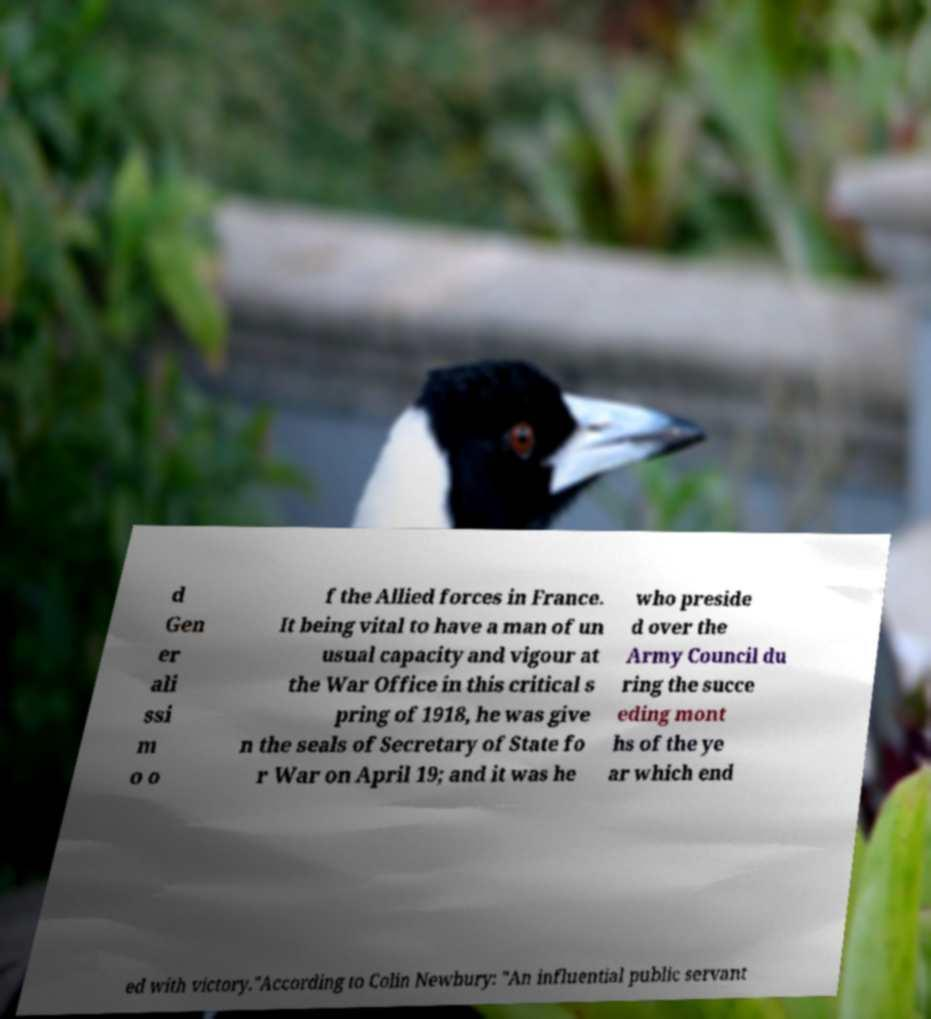Can you accurately transcribe the text from the provided image for me? d Gen er ali ssi m o o f the Allied forces in France. It being vital to have a man of un usual capacity and vigour at the War Office in this critical s pring of 1918, he was give n the seals of Secretary of State fo r War on April 19; and it was he who preside d over the Army Council du ring the succe eding mont hs of the ye ar which end ed with victory."According to Colin Newbury: "An influential public servant 